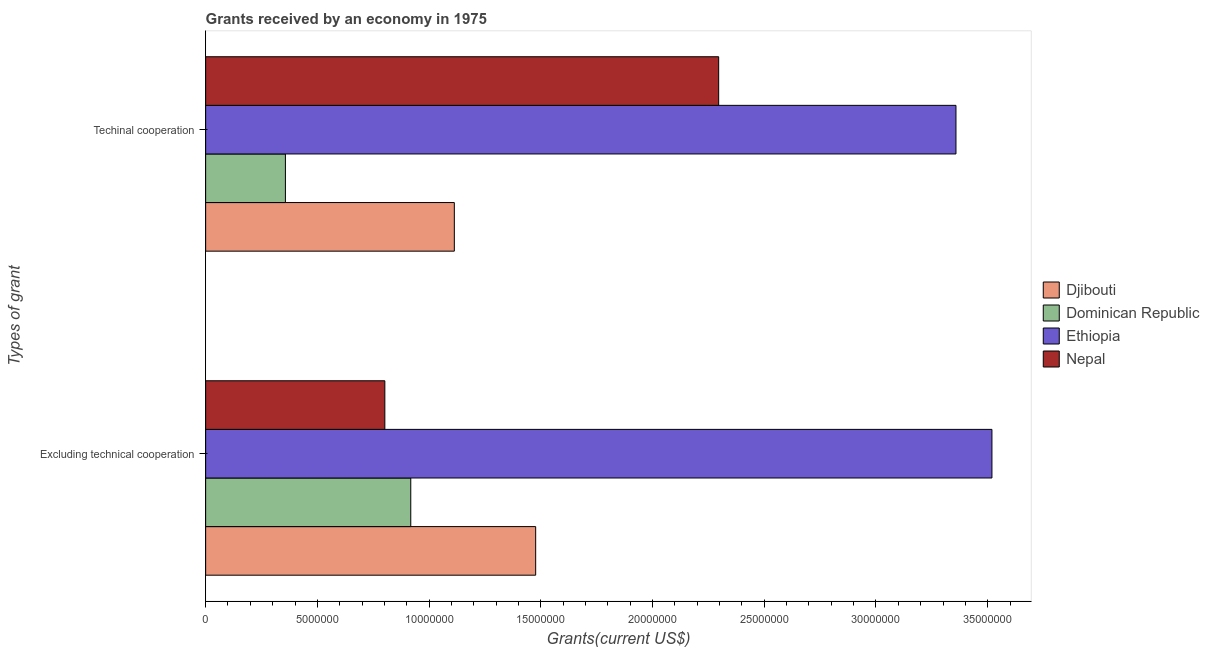How many bars are there on the 2nd tick from the top?
Your answer should be very brief. 4. How many bars are there on the 1st tick from the bottom?
Make the answer very short. 4. What is the label of the 1st group of bars from the top?
Your response must be concise. Techinal cooperation. What is the amount of grants received(excluding technical cooperation) in Nepal?
Offer a terse response. 8.02e+06. Across all countries, what is the maximum amount of grants received(excluding technical cooperation)?
Provide a succinct answer. 3.52e+07. Across all countries, what is the minimum amount of grants received(including technical cooperation)?
Give a very brief answer. 3.57e+06. In which country was the amount of grants received(including technical cooperation) maximum?
Provide a short and direct response. Ethiopia. In which country was the amount of grants received(including technical cooperation) minimum?
Keep it short and to the point. Dominican Republic. What is the total amount of grants received(excluding technical cooperation) in the graph?
Give a very brief answer. 6.72e+07. What is the difference between the amount of grants received(including technical cooperation) in Ethiopia and that in Dominican Republic?
Make the answer very short. 3.00e+07. What is the difference between the amount of grants received(including technical cooperation) in Djibouti and the amount of grants received(excluding technical cooperation) in Ethiopia?
Ensure brevity in your answer.  -2.41e+07. What is the average amount of grants received(including technical cooperation) per country?
Provide a succinct answer. 1.78e+07. What is the difference between the amount of grants received(excluding technical cooperation) and amount of grants received(including technical cooperation) in Ethiopia?
Your answer should be very brief. 1.61e+06. In how many countries, is the amount of grants received(including technical cooperation) greater than 34000000 US$?
Your answer should be compact. 0. What is the ratio of the amount of grants received(excluding technical cooperation) in Ethiopia to that in Nepal?
Make the answer very short. 4.39. Is the amount of grants received(excluding technical cooperation) in Dominican Republic less than that in Nepal?
Provide a short and direct response. No. In how many countries, is the amount of grants received(including technical cooperation) greater than the average amount of grants received(including technical cooperation) taken over all countries?
Offer a terse response. 2. What does the 2nd bar from the top in Excluding technical cooperation represents?
Keep it short and to the point. Ethiopia. What does the 3rd bar from the bottom in Excluding technical cooperation represents?
Your answer should be compact. Ethiopia. How many bars are there?
Make the answer very short. 8. Are all the bars in the graph horizontal?
Your answer should be compact. Yes. What is the difference between two consecutive major ticks on the X-axis?
Keep it short and to the point. 5.00e+06. How many legend labels are there?
Your answer should be compact. 4. How are the legend labels stacked?
Your answer should be compact. Vertical. What is the title of the graph?
Provide a short and direct response. Grants received by an economy in 1975. What is the label or title of the X-axis?
Provide a short and direct response. Grants(current US$). What is the label or title of the Y-axis?
Provide a succinct answer. Types of grant. What is the Grants(current US$) of Djibouti in Excluding technical cooperation?
Your answer should be very brief. 1.48e+07. What is the Grants(current US$) of Dominican Republic in Excluding technical cooperation?
Offer a very short reply. 9.18e+06. What is the Grants(current US$) in Ethiopia in Excluding technical cooperation?
Your answer should be compact. 3.52e+07. What is the Grants(current US$) in Nepal in Excluding technical cooperation?
Keep it short and to the point. 8.02e+06. What is the Grants(current US$) in Djibouti in Techinal cooperation?
Provide a succinct answer. 1.11e+07. What is the Grants(current US$) of Dominican Republic in Techinal cooperation?
Offer a terse response. 3.57e+06. What is the Grants(current US$) in Ethiopia in Techinal cooperation?
Ensure brevity in your answer.  3.36e+07. What is the Grants(current US$) in Nepal in Techinal cooperation?
Give a very brief answer. 2.30e+07. Across all Types of grant, what is the maximum Grants(current US$) of Djibouti?
Make the answer very short. 1.48e+07. Across all Types of grant, what is the maximum Grants(current US$) of Dominican Republic?
Give a very brief answer. 9.18e+06. Across all Types of grant, what is the maximum Grants(current US$) in Ethiopia?
Ensure brevity in your answer.  3.52e+07. Across all Types of grant, what is the maximum Grants(current US$) of Nepal?
Ensure brevity in your answer.  2.30e+07. Across all Types of grant, what is the minimum Grants(current US$) of Djibouti?
Your answer should be very brief. 1.11e+07. Across all Types of grant, what is the minimum Grants(current US$) in Dominican Republic?
Offer a terse response. 3.57e+06. Across all Types of grant, what is the minimum Grants(current US$) of Ethiopia?
Your answer should be very brief. 3.36e+07. Across all Types of grant, what is the minimum Grants(current US$) in Nepal?
Your answer should be very brief. 8.02e+06. What is the total Grants(current US$) of Djibouti in the graph?
Provide a succinct answer. 2.59e+07. What is the total Grants(current US$) in Dominican Republic in the graph?
Offer a very short reply. 1.28e+07. What is the total Grants(current US$) of Ethiopia in the graph?
Make the answer very short. 6.88e+07. What is the total Grants(current US$) of Nepal in the graph?
Provide a succinct answer. 3.10e+07. What is the difference between the Grants(current US$) of Djibouti in Excluding technical cooperation and that in Techinal cooperation?
Provide a succinct answer. 3.64e+06. What is the difference between the Grants(current US$) of Dominican Republic in Excluding technical cooperation and that in Techinal cooperation?
Your answer should be compact. 5.61e+06. What is the difference between the Grants(current US$) of Ethiopia in Excluding technical cooperation and that in Techinal cooperation?
Provide a succinct answer. 1.61e+06. What is the difference between the Grants(current US$) of Nepal in Excluding technical cooperation and that in Techinal cooperation?
Keep it short and to the point. -1.49e+07. What is the difference between the Grants(current US$) of Djibouti in Excluding technical cooperation and the Grants(current US$) of Dominican Republic in Techinal cooperation?
Offer a terse response. 1.12e+07. What is the difference between the Grants(current US$) in Djibouti in Excluding technical cooperation and the Grants(current US$) in Ethiopia in Techinal cooperation?
Provide a succinct answer. -1.88e+07. What is the difference between the Grants(current US$) in Djibouti in Excluding technical cooperation and the Grants(current US$) in Nepal in Techinal cooperation?
Offer a terse response. -8.19e+06. What is the difference between the Grants(current US$) in Dominican Republic in Excluding technical cooperation and the Grants(current US$) in Ethiopia in Techinal cooperation?
Provide a succinct answer. -2.44e+07. What is the difference between the Grants(current US$) of Dominican Republic in Excluding technical cooperation and the Grants(current US$) of Nepal in Techinal cooperation?
Offer a very short reply. -1.38e+07. What is the difference between the Grants(current US$) of Ethiopia in Excluding technical cooperation and the Grants(current US$) of Nepal in Techinal cooperation?
Make the answer very short. 1.22e+07. What is the average Grants(current US$) in Djibouti per Types of grant?
Make the answer very short. 1.30e+07. What is the average Grants(current US$) in Dominican Republic per Types of grant?
Provide a succinct answer. 6.38e+06. What is the average Grants(current US$) of Ethiopia per Types of grant?
Offer a terse response. 3.44e+07. What is the average Grants(current US$) of Nepal per Types of grant?
Give a very brief answer. 1.55e+07. What is the difference between the Grants(current US$) in Djibouti and Grants(current US$) in Dominican Republic in Excluding technical cooperation?
Offer a terse response. 5.59e+06. What is the difference between the Grants(current US$) of Djibouti and Grants(current US$) of Ethiopia in Excluding technical cooperation?
Your answer should be compact. -2.04e+07. What is the difference between the Grants(current US$) of Djibouti and Grants(current US$) of Nepal in Excluding technical cooperation?
Ensure brevity in your answer.  6.75e+06. What is the difference between the Grants(current US$) in Dominican Republic and Grants(current US$) in Ethiopia in Excluding technical cooperation?
Give a very brief answer. -2.60e+07. What is the difference between the Grants(current US$) in Dominican Republic and Grants(current US$) in Nepal in Excluding technical cooperation?
Offer a terse response. 1.16e+06. What is the difference between the Grants(current US$) of Ethiopia and Grants(current US$) of Nepal in Excluding technical cooperation?
Make the answer very short. 2.72e+07. What is the difference between the Grants(current US$) of Djibouti and Grants(current US$) of Dominican Republic in Techinal cooperation?
Ensure brevity in your answer.  7.56e+06. What is the difference between the Grants(current US$) of Djibouti and Grants(current US$) of Ethiopia in Techinal cooperation?
Ensure brevity in your answer.  -2.24e+07. What is the difference between the Grants(current US$) in Djibouti and Grants(current US$) in Nepal in Techinal cooperation?
Provide a succinct answer. -1.18e+07. What is the difference between the Grants(current US$) of Dominican Republic and Grants(current US$) of Ethiopia in Techinal cooperation?
Provide a succinct answer. -3.00e+07. What is the difference between the Grants(current US$) in Dominican Republic and Grants(current US$) in Nepal in Techinal cooperation?
Make the answer very short. -1.94e+07. What is the difference between the Grants(current US$) in Ethiopia and Grants(current US$) in Nepal in Techinal cooperation?
Make the answer very short. 1.06e+07. What is the ratio of the Grants(current US$) of Djibouti in Excluding technical cooperation to that in Techinal cooperation?
Your answer should be very brief. 1.33. What is the ratio of the Grants(current US$) of Dominican Republic in Excluding technical cooperation to that in Techinal cooperation?
Provide a short and direct response. 2.57. What is the ratio of the Grants(current US$) in Ethiopia in Excluding technical cooperation to that in Techinal cooperation?
Ensure brevity in your answer.  1.05. What is the ratio of the Grants(current US$) in Nepal in Excluding technical cooperation to that in Techinal cooperation?
Your answer should be very brief. 0.35. What is the difference between the highest and the second highest Grants(current US$) in Djibouti?
Give a very brief answer. 3.64e+06. What is the difference between the highest and the second highest Grants(current US$) of Dominican Republic?
Provide a short and direct response. 5.61e+06. What is the difference between the highest and the second highest Grants(current US$) of Ethiopia?
Provide a succinct answer. 1.61e+06. What is the difference between the highest and the second highest Grants(current US$) in Nepal?
Keep it short and to the point. 1.49e+07. What is the difference between the highest and the lowest Grants(current US$) in Djibouti?
Your response must be concise. 3.64e+06. What is the difference between the highest and the lowest Grants(current US$) of Dominican Republic?
Provide a short and direct response. 5.61e+06. What is the difference between the highest and the lowest Grants(current US$) of Ethiopia?
Provide a short and direct response. 1.61e+06. What is the difference between the highest and the lowest Grants(current US$) of Nepal?
Ensure brevity in your answer.  1.49e+07. 